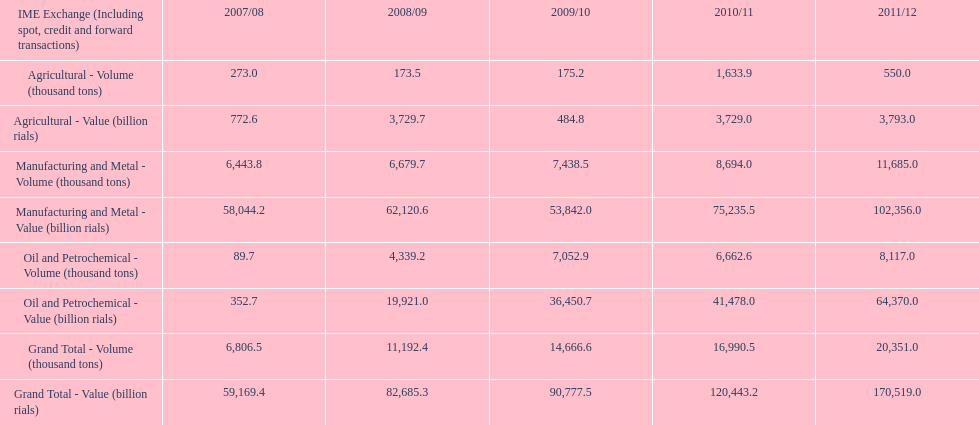In which year was the highest value achieved for manufacturing and metal in iran? 2011/12. 